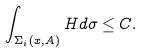Convert formula to latex. <formula><loc_0><loc_0><loc_500><loc_500>\int _ { \Sigma _ { i } ( x , A ) } H d \sigma \leq C .</formula> 